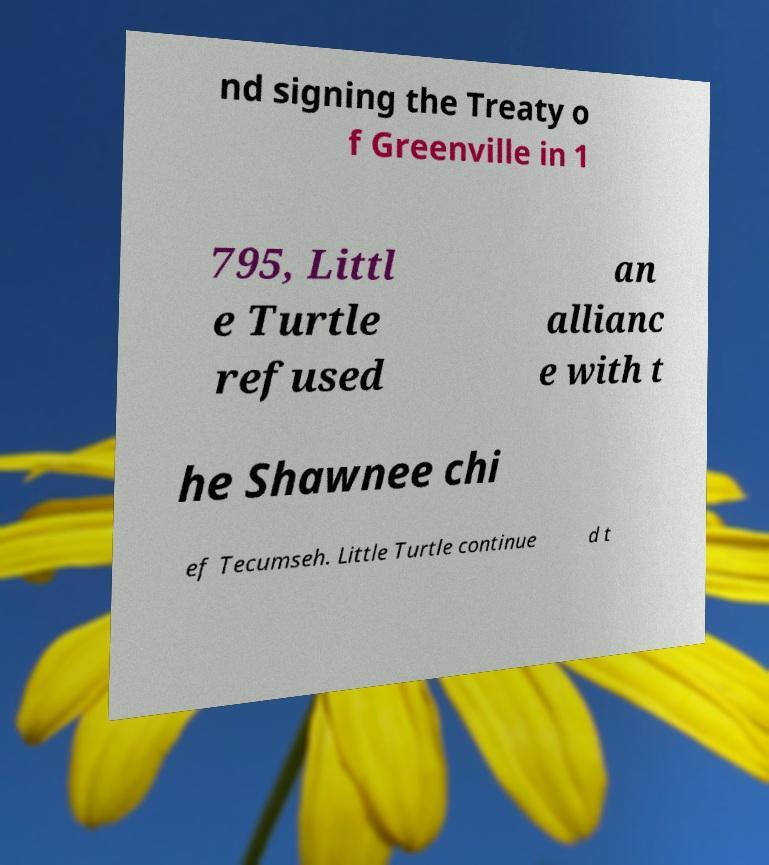I need the written content from this picture converted into text. Can you do that? nd signing the Treaty o f Greenville in 1 795, Littl e Turtle refused an allianc e with t he Shawnee chi ef Tecumseh. Little Turtle continue d t 